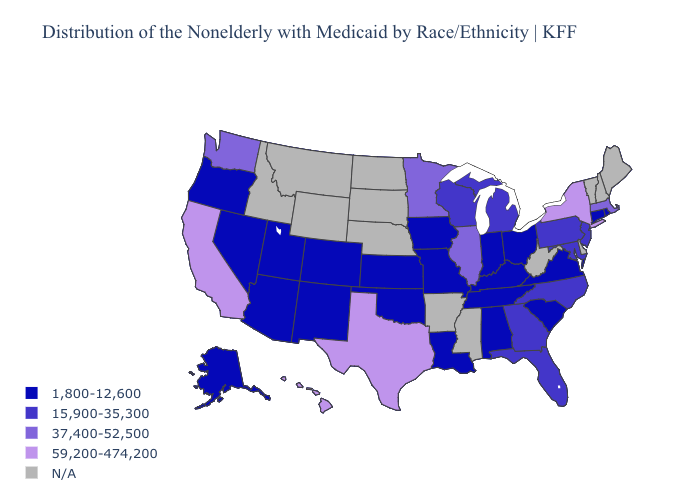Name the states that have a value in the range 37,400-52,500?
Short answer required. Illinois, Massachusetts, Minnesota, Washington. Is the legend a continuous bar?
Give a very brief answer. No. What is the lowest value in states that border Florida?
Write a very short answer. 1,800-12,600. What is the value of New York?
Keep it brief. 59,200-474,200. Which states have the highest value in the USA?
Answer briefly. California, Hawaii, New York, Texas. What is the value of Wisconsin?
Write a very short answer. 15,900-35,300. Name the states that have a value in the range 15,900-35,300?
Concise answer only. Florida, Georgia, Maryland, Michigan, New Jersey, North Carolina, Pennsylvania, Wisconsin. Which states hav the highest value in the West?
Answer briefly. California, Hawaii. What is the highest value in the West ?
Be succinct. 59,200-474,200. Among the states that border Indiana , which have the highest value?
Write a very short answer. Illinois. Which states have the highest value in the USA?
Be succinct. California, Hawaii, New York, Texas. Name the states that have a value in the range N/A?
Keep it brief. Arkansas, Delaware, Idaho, Maine, Mississippi, Montana, Nebraska, New Hampshire, North Dakota, South Dakota, Vermont, West Virginia, Wyoming. What is the highest value in the USA?
Concise answer only. 59,200-474,200. Name the states that have a value in the range 1,800-12,600?
Short answer required. Alabama, Alaska, Arizona, Colorado, Connecticut, Indiana, Iowa, Kansas, Kentucky, Louisiana, Missouri, Nevada, New Mexico, Ohio, Oklahoma, Oregon, Rhode Island, South Carolina, Tennessee, Utah, Virginia. 